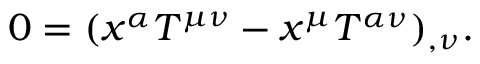Convert formula to latex. <formula><loc_0><loc_0><loc_500><loc_500>0 = ( x ^ { \alpha } T ^ { \mu \nu } - x ^ { \mu } T ^ { \alpha \nu } ) _ { , \nu } .</formula> 